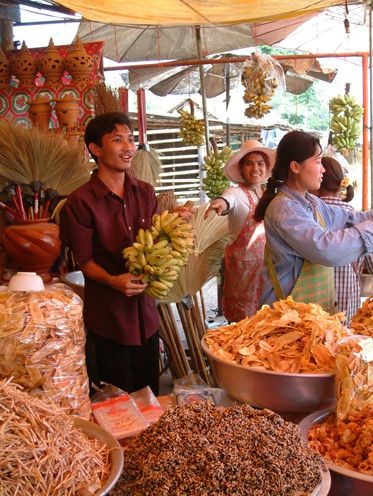Describe the objects in this image and their specific colors. I can see people in black, maroon, and brown tones, people in black, gray, and darkgray tones, umbrella in black, tan, and gray tones, people in black, maroon, brown, and lightpink tones, and bowl in black, maroon, and brown tones in this image. 